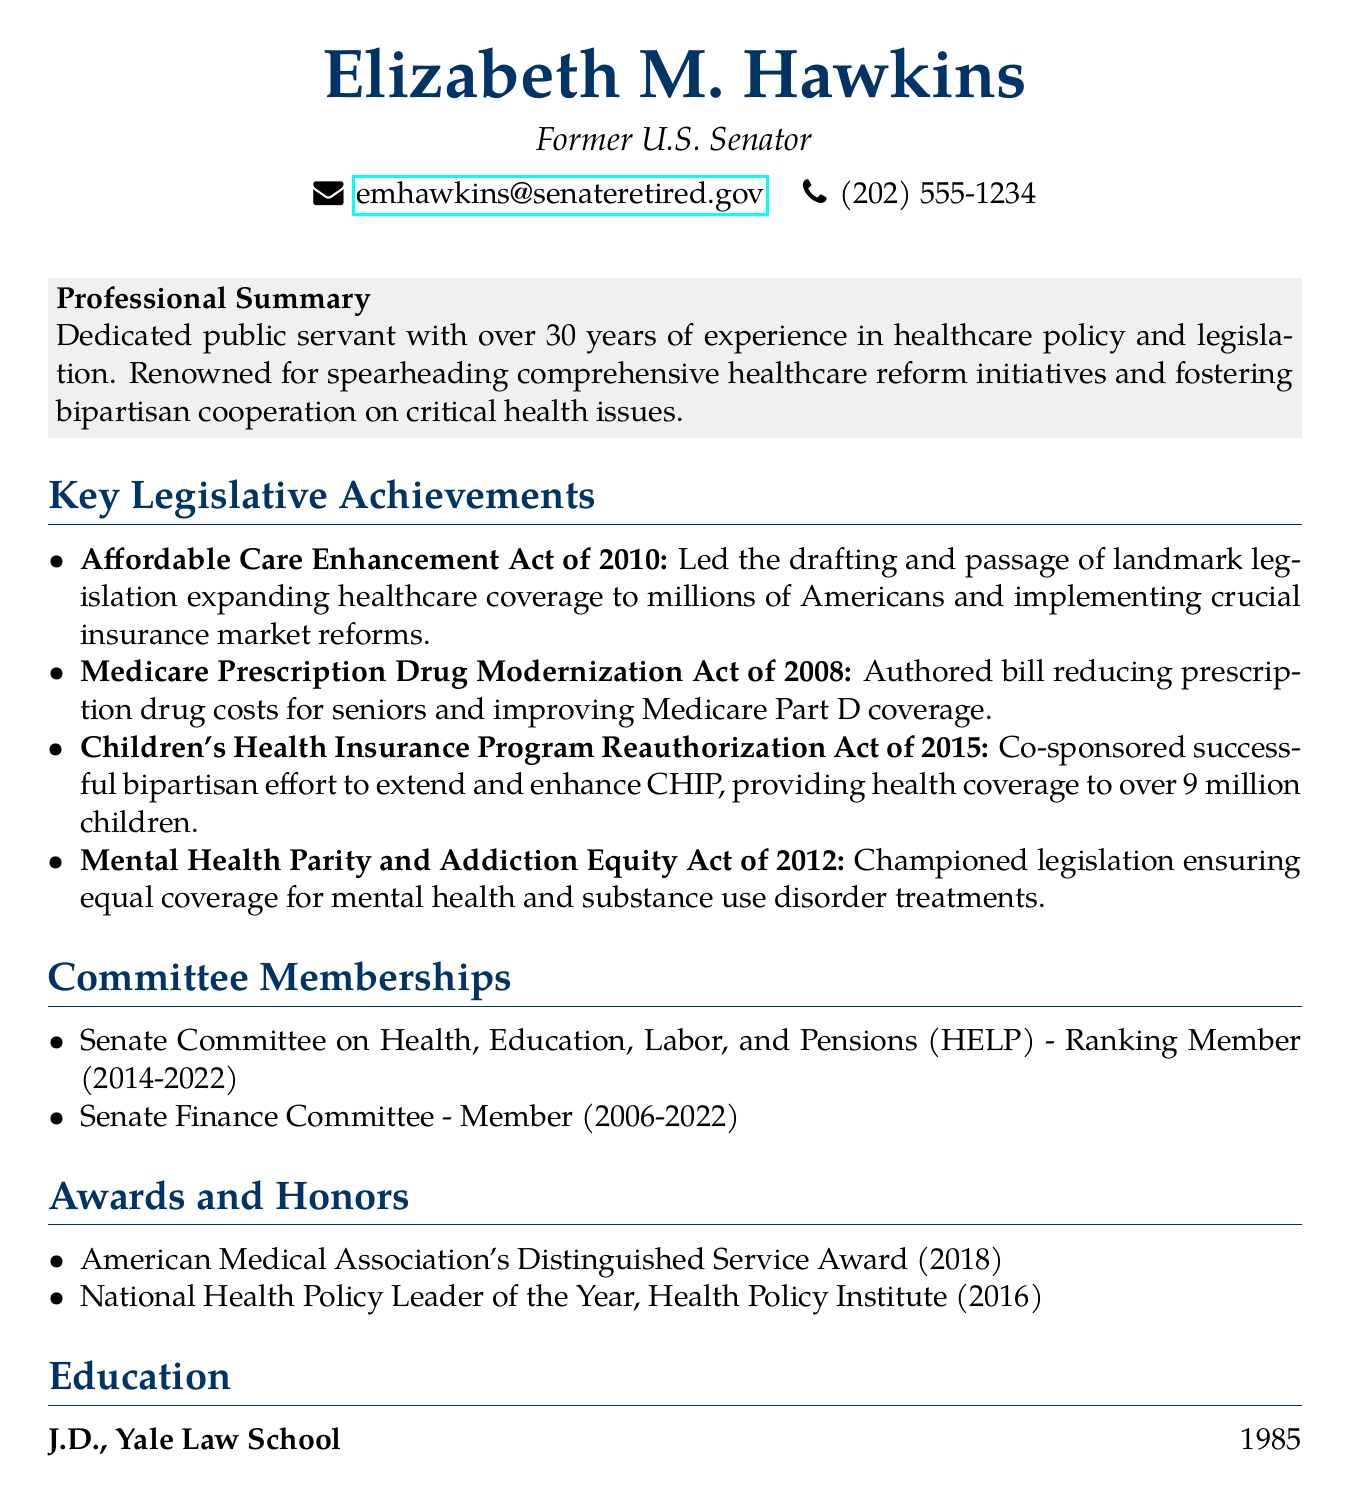What is Elizabeth M. Hawkins' title? Her title, as stated in the document, is "Former U.S. Senator."
Answer: Former U.S. Senator What year did Elizabeth earn her J.D. degree? The document specifies that she obtained her J.D. degree in 1985.
Answer: 1985 Which act focused on mental health and substance use disorder? The document mentions the "Mental Health Parity and Addiction Equity Act of 2012" that addresses this issue.
Answer: Mental Health Parity and Addiction Equity Act of 2012 How many children are covered under the Children's Health Insurance Program Reauthorization Act? The document states that the CHIP provides health coverage to over 9 million children.
Answer: 9 million What professional recognition did Elizabeth receive in 2018? The document notes she received the "American Medical Association's Distinguished Service Award."
Answer: American Medical Association's Distinguished Service Award Who was the Ranking Member of the Senate Committee on Health, Education, Labor, and Pensions from 2014 to 2022? The document indicates that Elizabeth M. Hawkins held this position during that timeframe.
Answer: Elizabeth M. Hawkins Which healthcare initiative was passed in 2010? According to the document, it was the "Affordable Care Enhancement Act of 2010."
Answer: Affordable Care Enhancement Act of 2010 What is the focus of the Medicare Prescription Drug Modernization Act? The document describes it as reducing prescription drug costs for seniors and improving Medicare Part D coverage.
Answer: Reducing prescription drug costs for seniors 